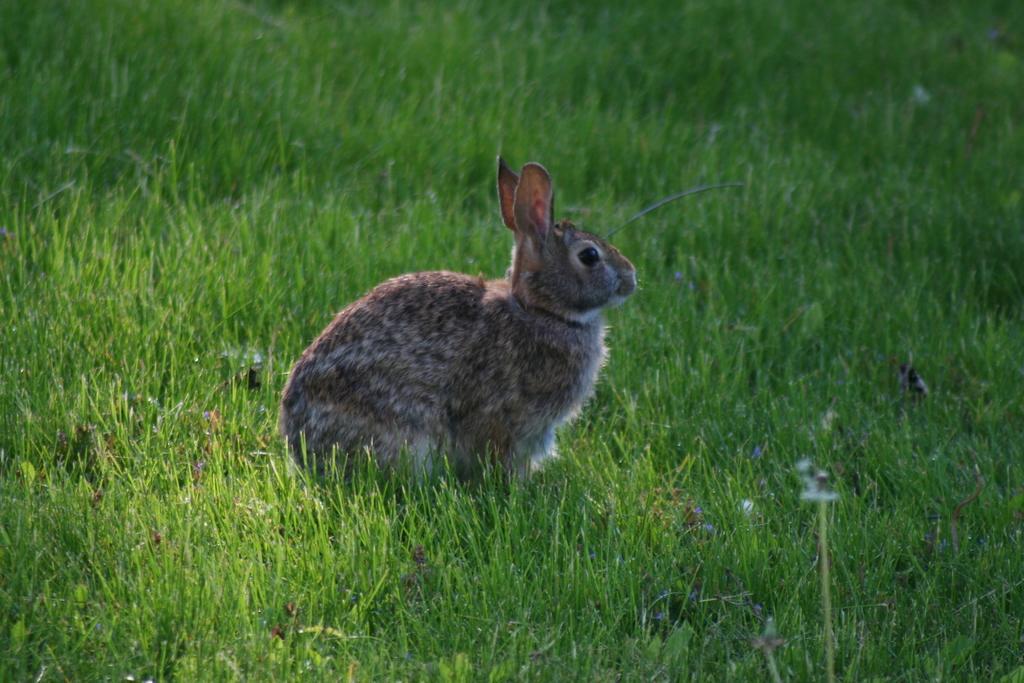Can you describe this image briefly? In the middle of this image there is a rabbit facing towards the right side. Here I can see the grass on the ground. 